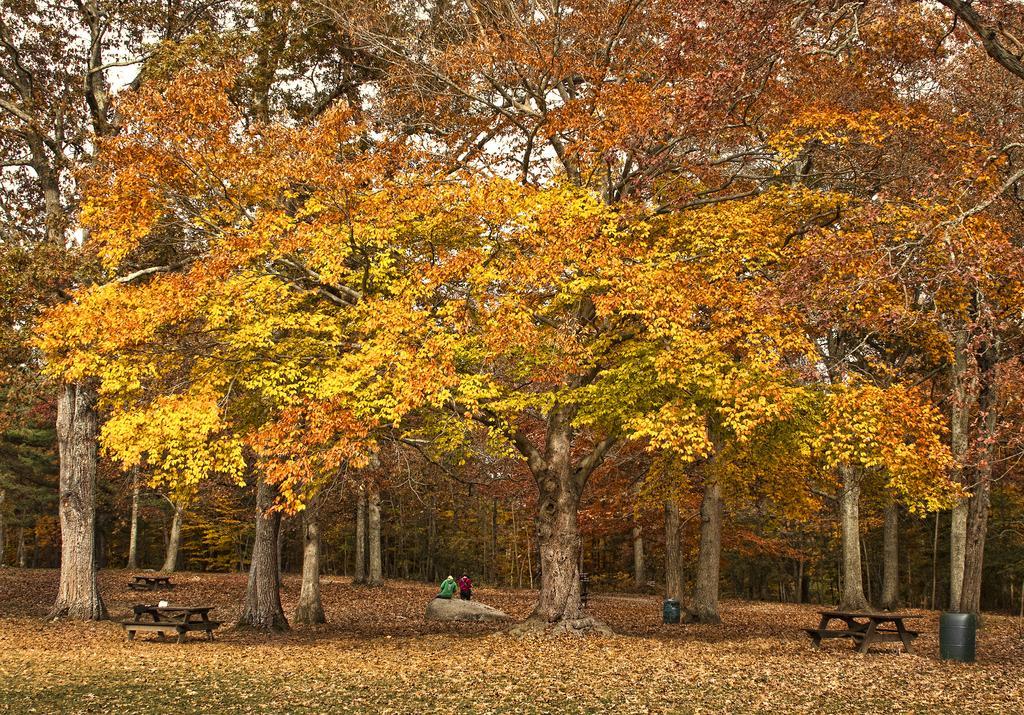Please provide a concise description of this image. In the picture we can see a grass surface on it, we can see, full of dried leaves and on it we can see some benches and in one bench we can see two people are sitting and in the background we can see full of trees with maple leaves to it. 